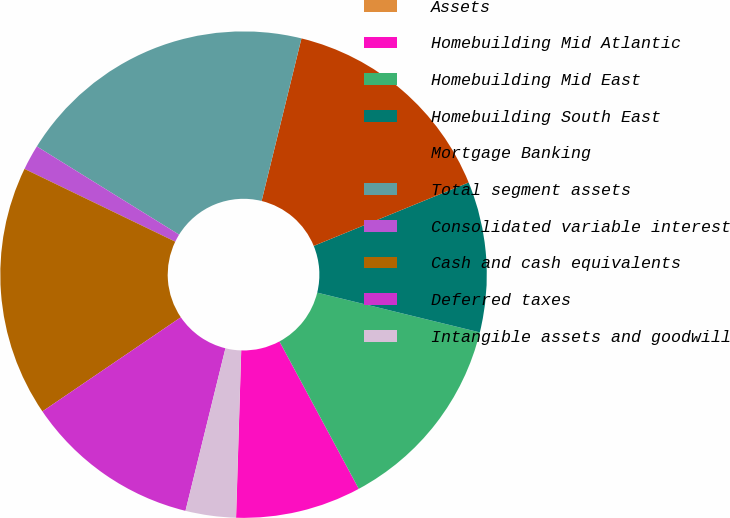Convert chart. <chart><loc_0><loc_0><loc_500><loc_500><pie_chart><fcel>Assets<fcel>Homebuilding Mid Atlantic<fcel>Homebuilding Mid East<fcel>Homebuilding South East<fcel>Mortgage Banking<fcel>Total segment assets<fcel>Consolidated variable interest<fcel>Cash and cash equivalents<fcel>Deferred taxes<fcel>Intangible assets and goodwill<nl><fcel>0.01%<fcel>8.34%<fcel>13.33%<fcel>10.0%<fcel>14.99%<fcel>19.99%<fcel>1.68%<fcel>16.66%<fcel>11.66%<fcel>3.34%<nl></chart> 